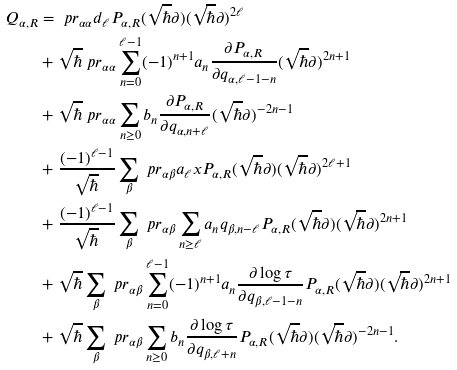Convert formula to latex. <formula><loc_0><loc_0><loc_500><loc_500>Q _ { \alpha , R } & = \ p r _ { \alpha \alpha } d _ { \ell } P _ { \alpha , R } ( \sqrt { \hbar } \partial ) ( \sqrt { \hbar } \partial ) ^ { 2 \ell } \\ & + { \sqrt { \hbar } } { \ p r _ { \alpha \alpha } } \sum _ { n = 0 } ^ { \ell - 1 } ( - 1 ) ^ { n + 1 } a _ { n } \frac { \partial P _ { \alpha , R } } { \partial q _ { \alpha , \ell - 1 - n } } ( \sqrt { \hbar } \partial ) ^ { 2 n + 1 } \\ & + { \sqrt { \hbar } } { \ p r _ { \alpha \alpha } } \sum _ { n \geq 0 } b _ { n } \frac { \partial P _ { \alpha , R } } { \partial q _ { \alpha , n + \ell } } ( \sqrt { \hbar } \partial ) ^ { - 2 n - 1 } \\ & + \frac { ( - 1 ) ^ { \ell - 1 } } { \sqrt { \hbar } } \sum _ { \beta } \ p r _ { \alpha \beta } a _ { \ell } x P _ { \alpha , R } ( \sqrt { \hbar } \partial ) ( \sqrt { \hbar } \partial ) ^ { 2 \ell + 1 } \\ & + \frac { ( - 1 ) ^ { \ell - 1 } } { \sqrt { \hbar } } \sum _ { \beta } \ p r _ { \alpha \beta } \sum _ { n \geq \ell } a _ { n } q _ { \beta , n - \ell } P _ { \alpha , R } ( \sqrt { \hbar } \partial ) ( \sqrt { \hbar } \partial ) ^ { 2 n + 1 } \\ & + { \sqrt { \hbar } } \sum _ { \beta } \ p r _ { \alpha \beta } \sum _ { n = 0 } ^ { \ell - 1 } ( - 1 ) ^ { n + 1 } a _ { n } \frac { \partial \log \tau } { \partial q _ { \beta , \ell - 1 - n } } P _ { \alpha , R } ( \sqrt { \hbar } \partial ) ( \sqrt { \hbar } \partial ) ^ { 2 n + 1 } \\ & + { \sqrt { \hbar } } \sum _ { \beta } \ p r _ { \alpha \beta } \sum _ { n \geq 0 } b _ { n } \frac { \partial \log \tau } { \partial q _ { \beta , \ell + n } } P _ { \alpha , R } ( \sqrt { \hbar } \partial ) ( \sqrt { \hbar } \partial ) ^ { - 2 n - 1 } .</formula> 